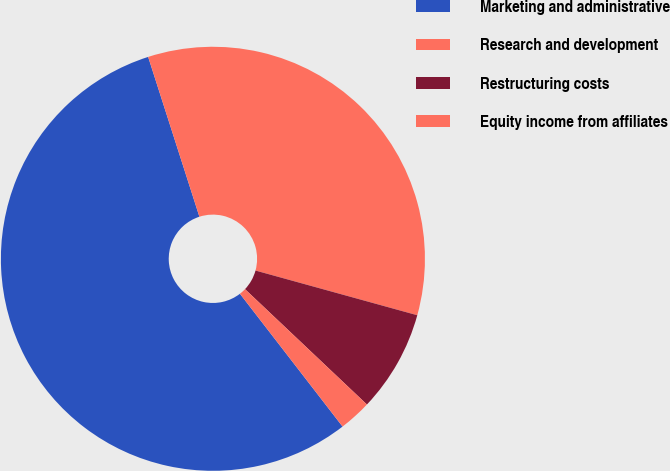Convert chart to OTSL. <chart><loc_0><loc_0><loc_500><loc_500><pie_chart><fcel>Marketing and administrative<fcel>Research and development<fcel>Restructuring costs<fcel>Equity income from affiliates<nl><fcel>55.53%<fcel>34.23%<fcel>7.77%<fcel>2.47%<nl></chart> 